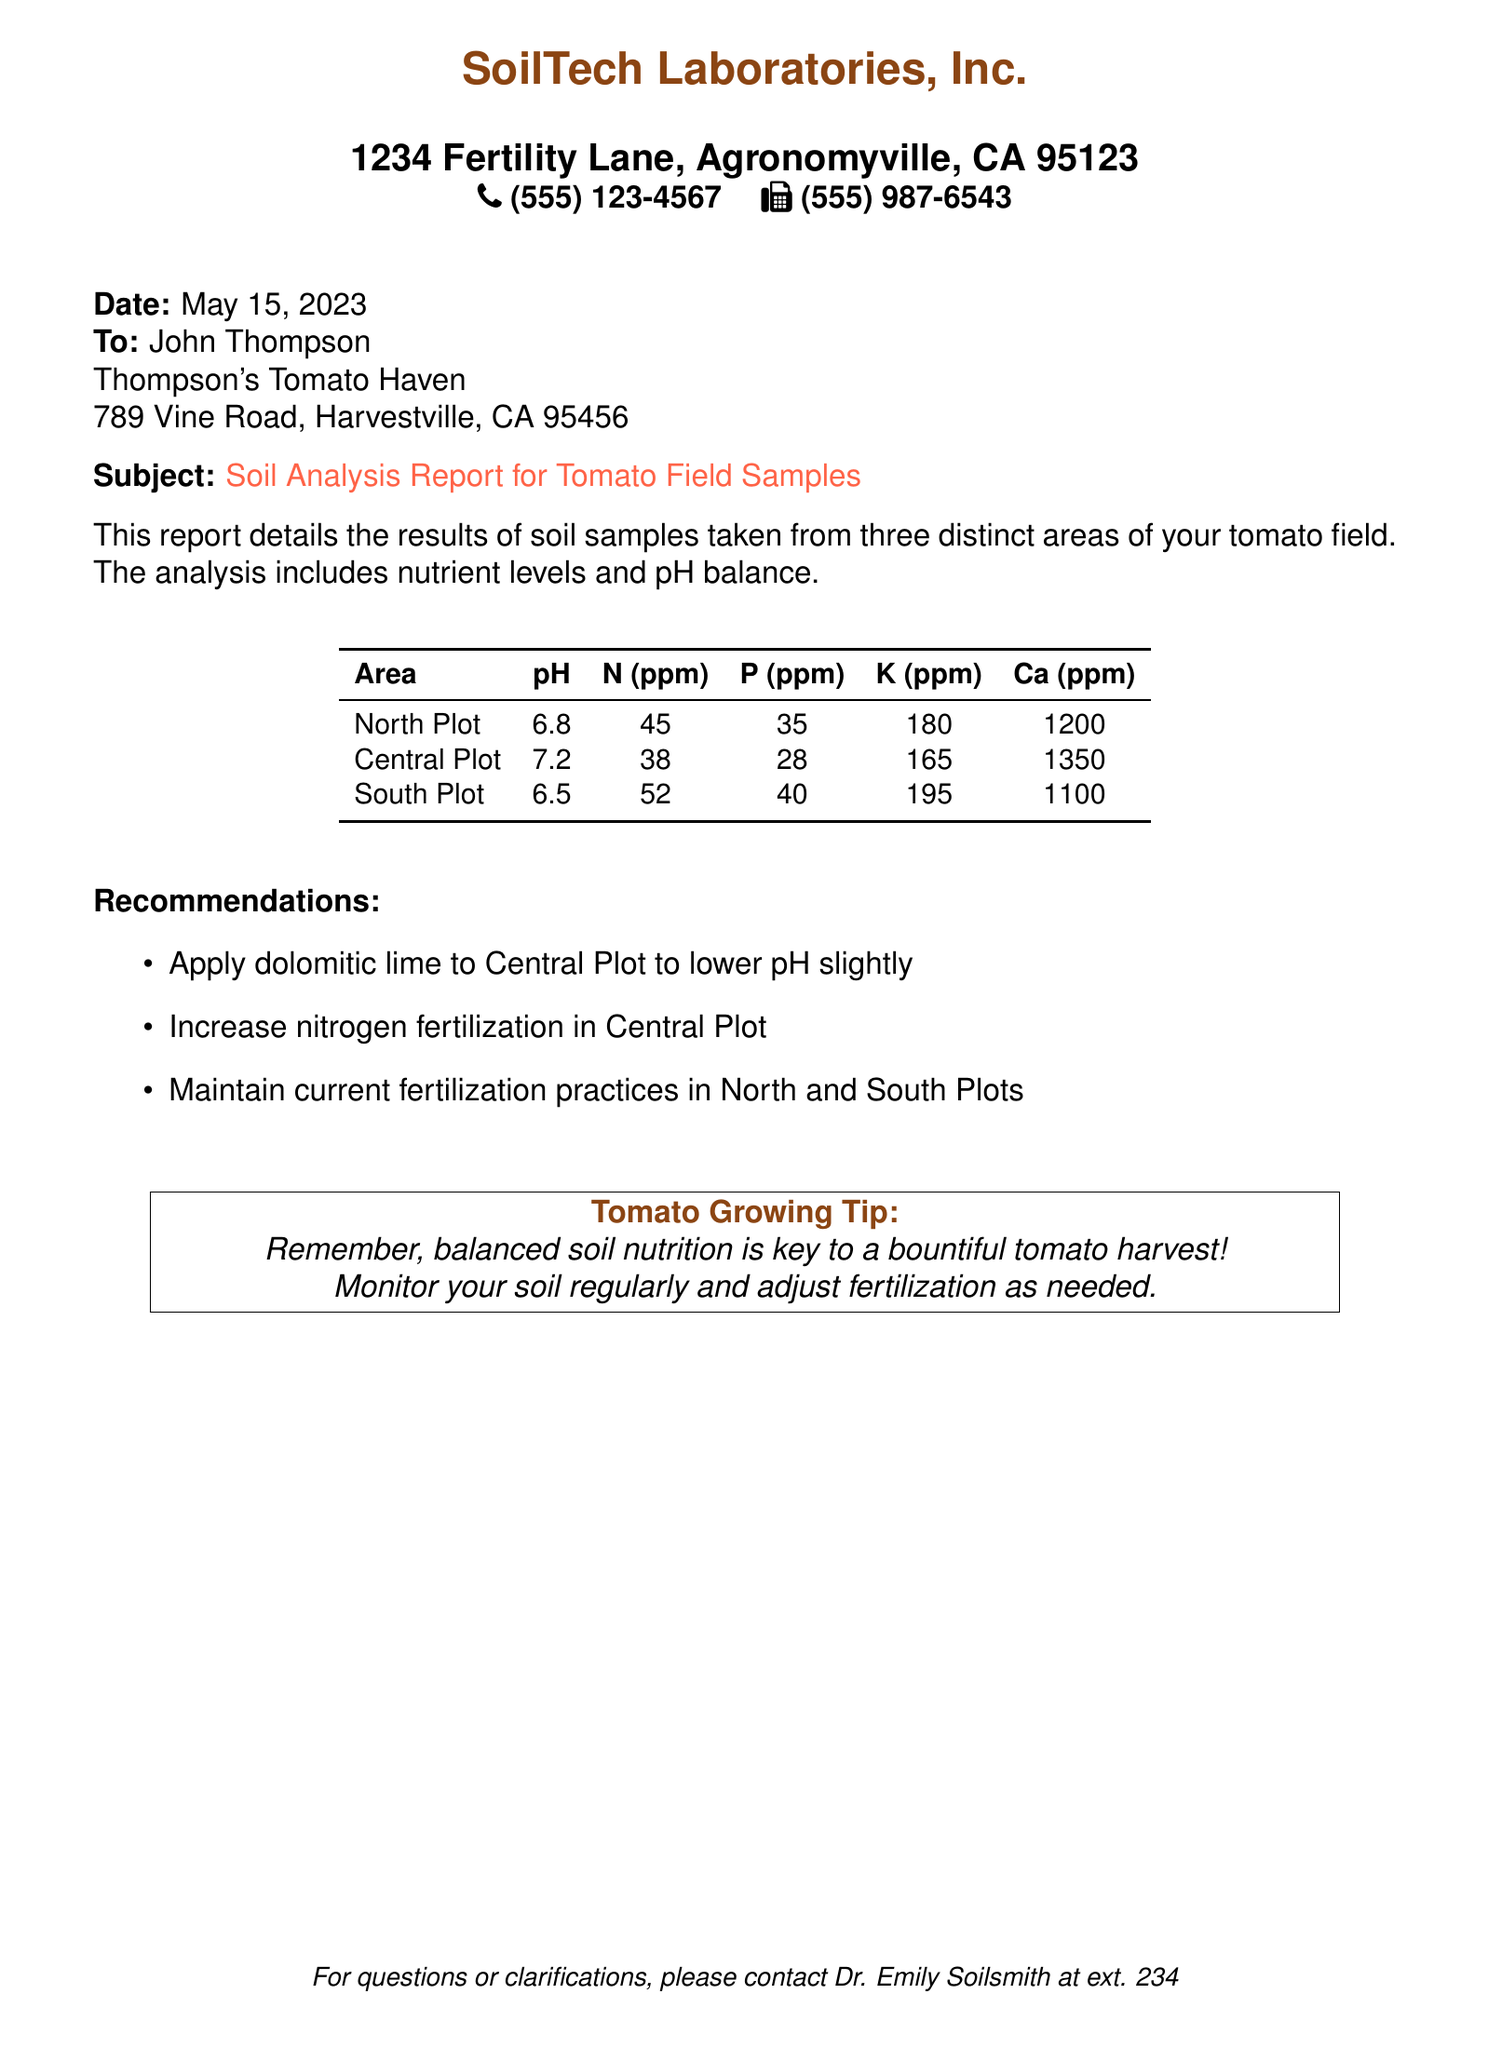What is the date of the report? The date in the document is stated as May 15, 2023.
Answer: May 15, 2023 Who is the contact person for questions? The document mentions Dr. Emily Soilsmith as the contact person for questions or clarifications.
Answer: Dr. Emily Soilsmith What is the pH level of the North Plot? The pH level for the North Plot is directly stated in the document under the respective table.
Answer: 6.8 Which plot has the highest potassium level? The potassium level for each plot needs to be compared, and South Plot has the highest value listed.
Answer: South Plot What recommendation is given for the Central Plot? The document lists specific recommendations for each plot and states that dolomitic lime should be applied to lower the pH.
Answer: Apply dolomitic lime How many parts per million (ppm) of calcium are in the Central Plot? The document explicitly provides the calcium level for the Central Plot in the table.
Answer: 1350 Which area has the lowest nitrogen level? The nitrogen levels were compared, and the Central Plot has the lowest nitrogen level stated.
Answer: Central Plot What is the address of SoilTech Laboratories? The document provides a specific address for the laboratory in the header section.
Answer: 1234 Fertility Lane, Agronomyville, CA 95123 